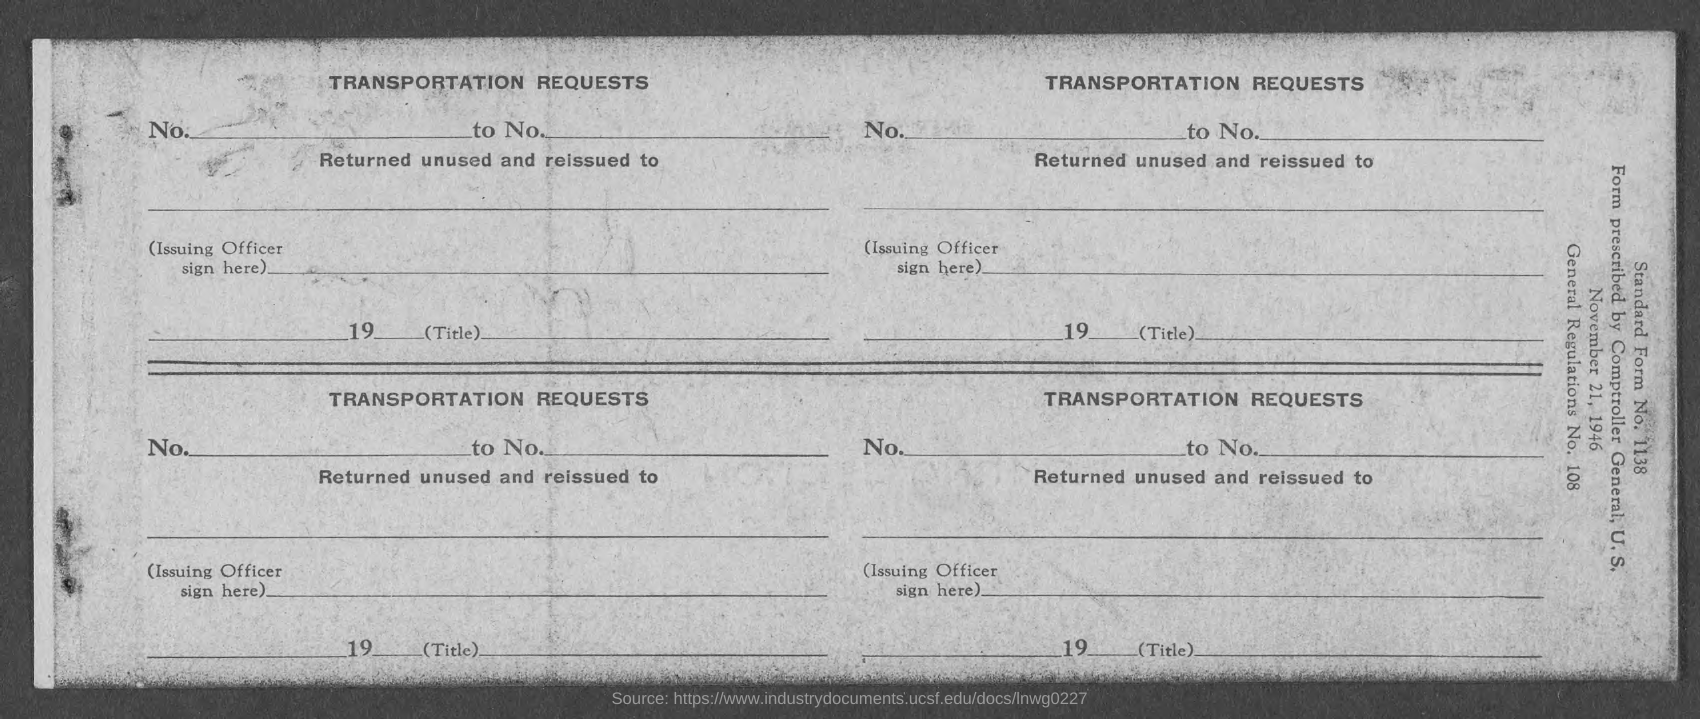Specify some key components in this picture. This is a transportation request document. 